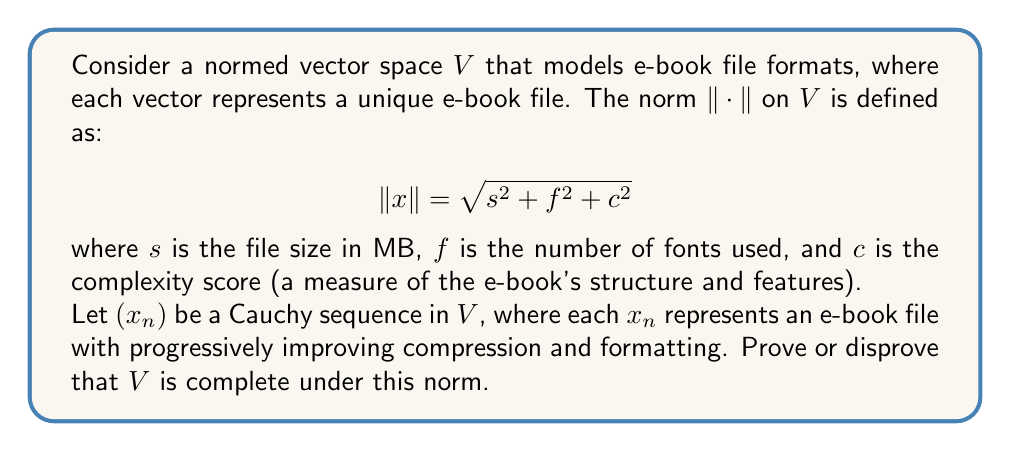Provide a solution to this math problem. To determine if the normed vector space $V$ is complete, we need to show that every Cauchy sequence in $V$ converges to an element in $V$. Let's approach this step-by-step:

1. Consider a Cauchy sequence $(x_n)$ in $V$. By definition, for any $\epsilon > 0$, there exists an $N \in \mathbb{N}$ such that for all $m, n > N$, we have:

   $$\|x_m - x_n\| < \epsilon$$

2. Let $x_n = (s_n, f_n, c_n)$ represent the nth e-book file in the sequence. The Cauchy criterion implies that for any $\epsilon > 0$, there exists an $N \in \mathbb{N}$ such that for all $m, n > N$:

   $$\sqrt{(s_m - s_n)^2 + (f_m - f_n)^2 + (c_m - c_n)^2} < \epsilon$$

3. This implies that $(s_n)$, $(f_n)$, and $(c_n)$ are Cauchy sequences in $\mathbb{R}$. Since $\mathbb{R}$ is complete, these sequences converge to limits $s$, $f$, and $c$ respectively.

4. Now, let $x = (s, f, c)$. We need to show that $x_n \to x$ in $V$. For any $\epsilon > 0$, there exists an $N \in \mathbb{N}$ such that for all $n > N$:

   $$|s_n - s| < \frac{\epsilon}{\sqrt{3}}, |f_n - f| < \frac{\epsilon}{\sqrt{3}}, |c_n - c| < \frac{\epsilon}{\sqrt{3}}$$

5. Therefore, for $n > N$:

   $$\|x_n - x\| = \sqrt{(s_n - s)^2 + (f_n - f)^2 + (c_n - c)^2} < \sqrt{3 \cdot (\frac{\epsilon}{\sqrt{3}})^2} = \epsilon$$

6. This proves that $x_n \to x$ in $V$. However, we need to ensure that $x \in V$. 

7. The file size $s$ is always non-negative and real. The number of fonts $f$, being a count, should be a non-negative integer. The complexity score $c$, as a measure, should also be non-negative and real.

8. Therefore, $x = (s, f, c)$ represents a valid e-book file in our model, and thus $x \in V$.

Thus, we have shown that every Cauchy sequence in $V$ converges to an element in $V$, proving that $V$ is complete under the given norm.
Answer: The normed vector space $V$ modeling e-book file formats is complete under the given norm. 